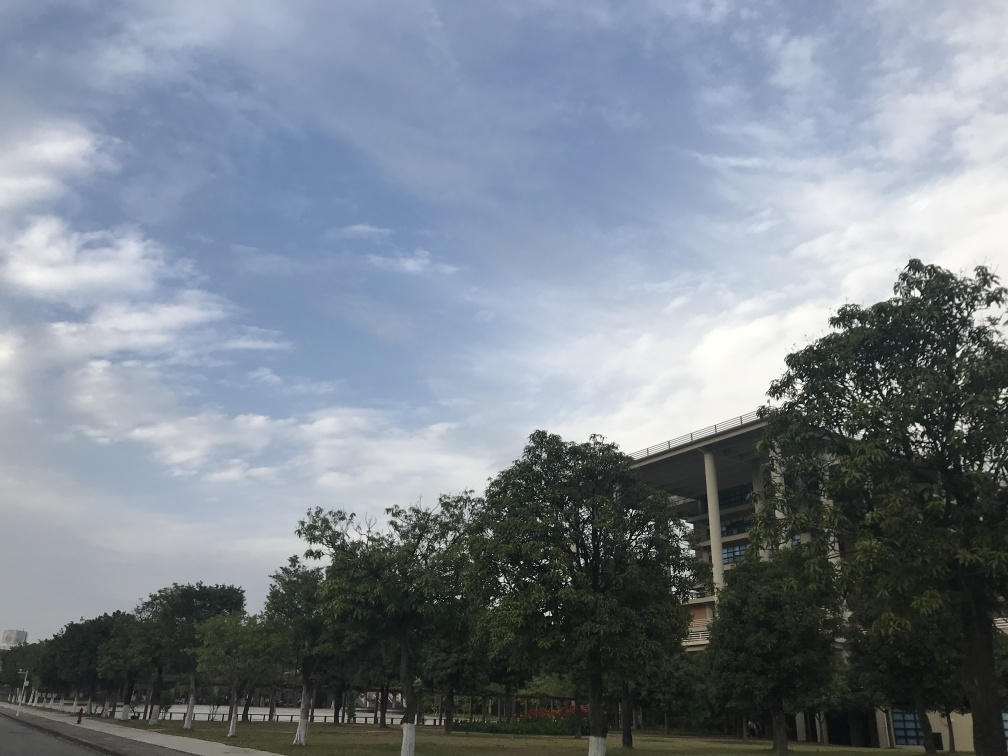Does the picture lack clarity? The image is clear, with good visibility. The sky is scattered with clouds suggesting a partially sunny day, and the environment appears calm, with trees lining an empty street alongside an architectural structure with multiple levels, possibly an office building or educational facility. 